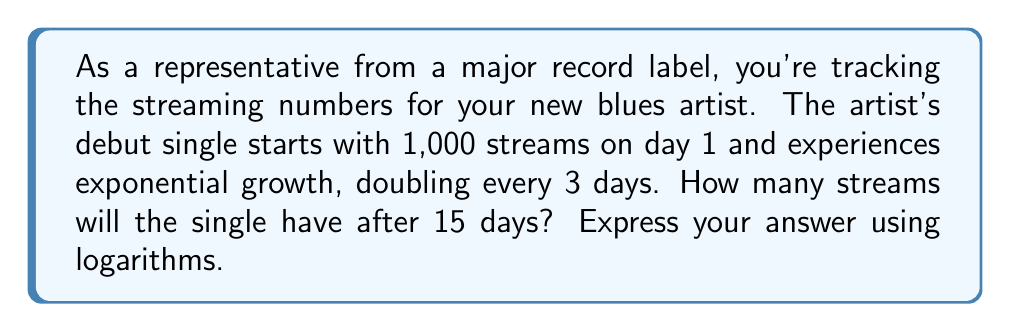What is the answer to this math problem? Let's approach this step-by-step:

1) We start with the exponential growth formula:
   $$ A = P(1 + r)^t $$
   Where A is the final amount, P is the initial amount, r is the growth rate, and t is the time.

2) In this case:
   P = 1,000 (initial streams)
   The number doubles every 3 days, so in 3 days it grows by a factor of 2.

3) To find the daily growth rate:
   $$ (1 + r)^3 = 2 $$
   $$ 1 + r = 2^{\frac{1}{3}} $$
   $$ r = 2^{\frac{1}{3}} - 1 \approx 0.2599 $$

4) Now, we can set up our equation for 15 days:
   $$ A = 1000(1 + 0.2599)^{15} $$

5) To simplify this using logarithms:
   $$ \log A = \log(1000) + 15 \log(1.2599) $$

6) Using the change of base formula:
   $$ A = 10^{\log(1000) + 15 \log(1.2599)} $$

This is the logarithmic expression for the number of streams after 15 days.
Answer: $$ A = 10^{\log(1000) + 15 \log(1.2599)} \approx 32,000 \text{ streams} $$ 